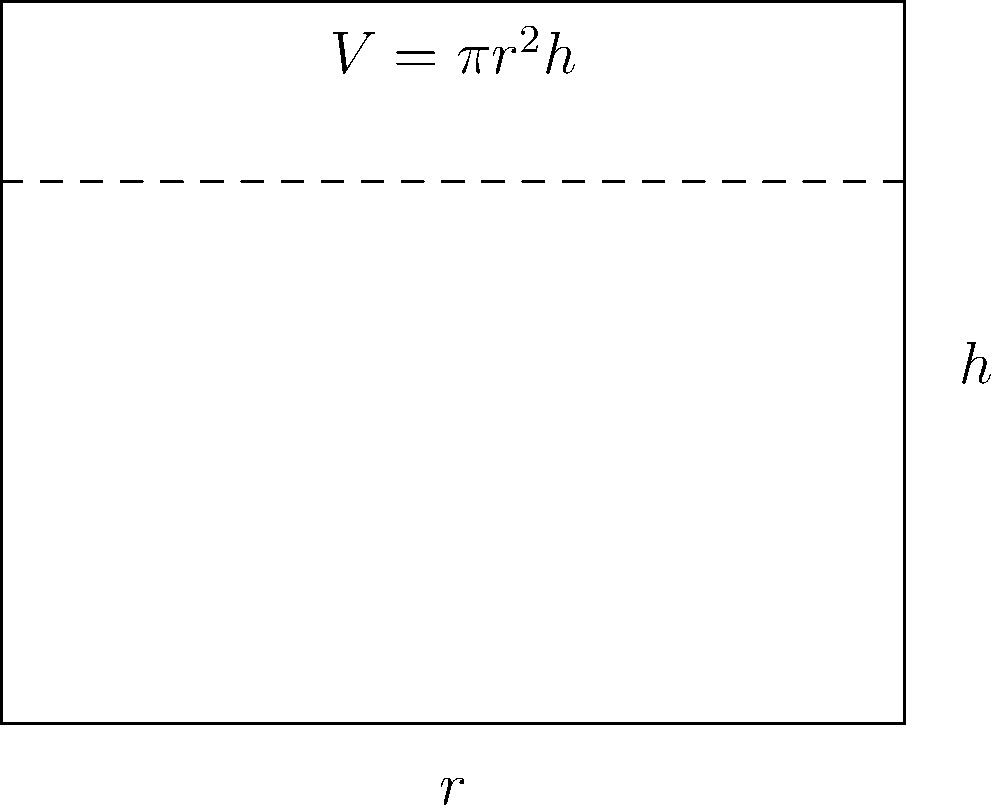Given that a cylindrical water tank needs to hold 1000 m³ of water and its height should be twice its radius, determine the optimal dimensions (radius and height) of the tank. Round your answer to the nearest 0.1 m. To solve this problem, we'll follow these steps:

1) First, we know that the volume of a cylinder is given by the formula:
   $$V = \pi r^2 h$$
   where $V$ is volume, $r$ is radius, and $h$ is height.

2) We're given that the height should be twice the radius:
   $$h = 2r$$

3) Substituting this into our volume formula:
   $$V = \pi r^2 (2r) = 2\pi r^3$$

4) We know the volume needs to be 1000 m³, so:
   $$1000 = 2\pi r^3$$

5) Solving for $r$:
   $$r^3 = \frac{1000}{2\pi} \approx 159.15$$
   $$r = \sqrt[3]{159.15} \approx 5.42$$

6) Rounding to the nearest 0.1 m:
   $$r \approx 5.4 \text{ m}$$

7) Since $h = 2r$:
   $$h \approx 10.8 \text{ m}$$

Therefore, the optimal dimensions are: radius ≈ 5.4 m and height ≈ 10.8 m.
Answer: $r \approx 5.4 \text{ m}, h \approx 10.8 \text{ m}$ 